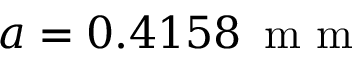Convert formula to latex. <formula><loc_0><loc_0><loc_500><loc_500>a = 0 . 4 1 5 8 \, m m</formula> 